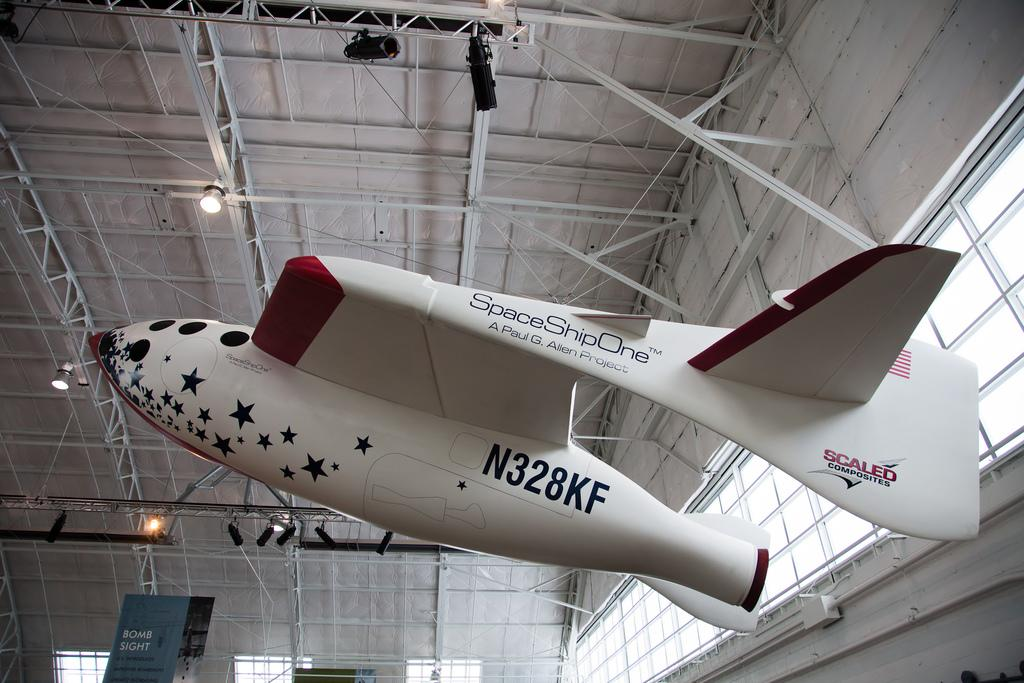Provide a one-sentence caption for the provided image. a space vessel called space ship one is hanging from the ceiling. 